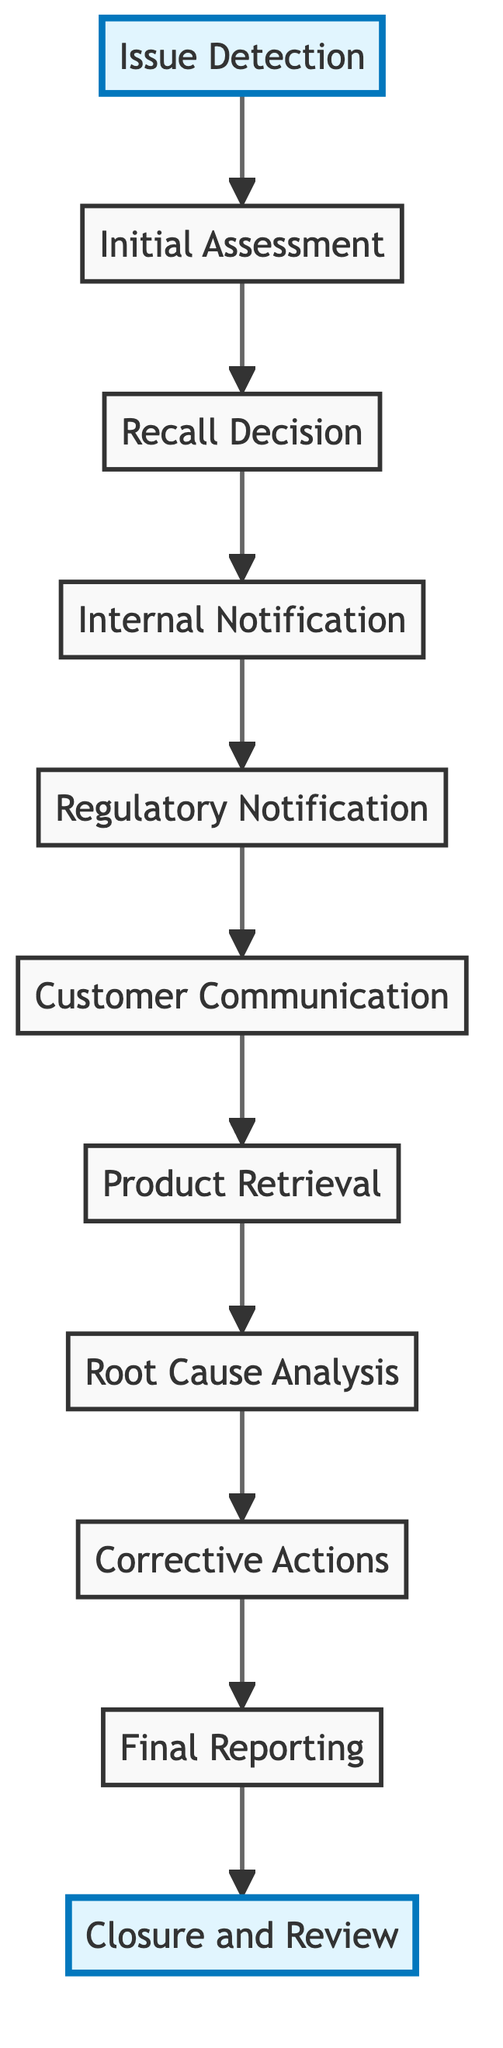What is the first step in the recall process? The diagram shows that "Issue Detection" is the first step, as indicated by the arrow pointing to "Initial Assessment."
Answer: Issue Detection How many steps are there in the recall process? By counting the nodes in the diagram, we find there are a total of 11 steps, starting from "Issue Detection" to "Closure and Review."
Answer: 11 What does the "Regulatory Notification" step involve? The diagram indicates that this step involves notifying regulatory authorities about the recall and providing information about the issue and affected products.
Answer: Notify regulatory authorities Which step comes after "Customer Communication"? Referring to the flow direction, "Product Retrieval" is the next step, as indicated by the arrow pointing upwards from "Customer Communication."
Answer: Product Retrieval What is the relationship between "Root Cause Analysis" and "Corrective Actions"? The flow chart shows that "Corrective Actions" directly follows "Root Cause Analysis," indicating the need for corrective measures after identifying the root causes of the issue.
Answer: Corrective Actions follows Root Cause Analysis What is the final step in the recall process? The last node in the flow chart is "Closure and Review," which indicates the end of the process.
Answer: Closure and Review How many notifications are listed in the recall process? The diagram includes two distinct notifications: "Internal Notification" and "Regulatory Notification."
Answer: 2 notifications What does the "Final Reporting" step entail? According to the flow chart, "Final Reporting" involves submitting a comprehensive report to regulatory authorities about the recall process and actions taken.
Answer: Submit a comprehensive report Which step is before "Recall Decision"? The step that comes immediately before "Recall Decision" according to the flow of the diagram is "Initial Assessment."
Answer: Initial Assessment What kinds of stakeholders are informed during "Internal Notification"? The "Internal Notification" step mentions informing internal stakeholders like manufacturing, supply chain, marketing, and sales teams.
Answer: Internal stakeholders 